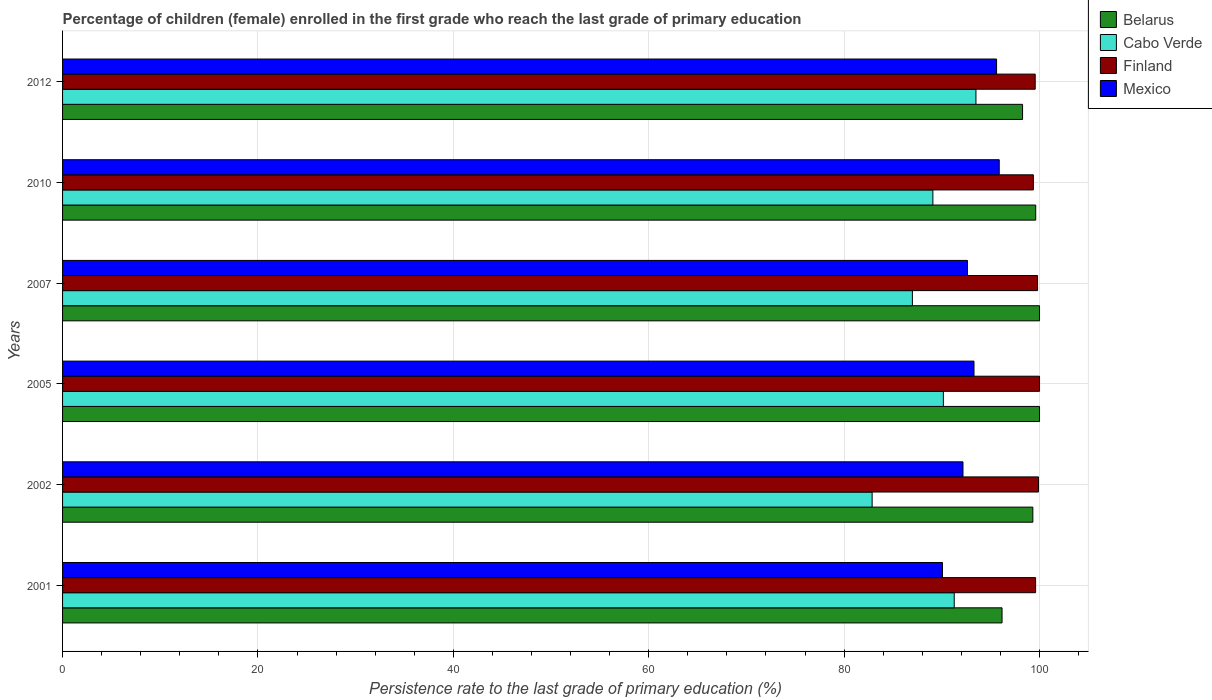How many bars are there on the 1st tick from the top?
Provide a short and direct response. 4. What is the label of the 4th group of bars from the top?
Your response must be concise. 2005. What is the persistence rate of children in Finland in 2001?
Offer a terse response. 99.6. Across all years, what is the maximum persistence rate of children in Cabo Verde?
Offer a terse response. 93.49. Across all years, what is the minimum persistence rate of children in Finland?
Offer a terse response. 99.37. In which year was the persistence rate of children in Cabo Verde maximum?
Your answer should be very brief. 2012. In which year was the persistence rate of children in Cabo Verde minimum?
Provide a succinct answer. 2002. What is the total persistence rate of children in Finland in the graph?
Provide a short and direct response. 598.21. What is the difference between the persistence rate of children in Finland in 2002 and that in 2012?
Offer a very short reply. 0.34. What is the difference between the persistence rate of children in Cabo Verde in 2005 and the persistence rate of children in Mexico in 2012?
Your answer should be very brief. -5.45. What is the average persistence rate of children in Cabo Verde per year?
Give a very brief answer. 88.98. In the year 2002, what is the difference between the persistence rate of children in Mexico and persistence rate of children in Cabo Verde?
Give a very brief answer. 9.3. In how many years, is the persistence rate of children in Mexico greater than 36 %?
Provide a succinct answer. 6. What is the ratio of the persistence rate of children in Finland in 2001 to that in 2007?
Keep it short and to the point. 1. Is the persistence rate of children in Cabo Verde in 2001 less than that in 2005?
Offer a terse response. No. Is the difference between the persistence rate of children in Mexico in 2005 and 2012 greater than the difference between the persistence rate of children in Cabo Verde in 2005 and 2012?
Your response must be concise. Yes. What is the difference between the highest and the second highest persistence rate of children in Mexico?
Offer a very short reply. 0.27. What is the difference between the highest and the lowest persistence rate of children in Mexico?
Provide a short and direct response. 5.81. Is the sum of the persistence rate of children in Belarus in 2001 and 2012 greater than the maximum persistence rate of children in Finland across all years?
Offer a very short reply. Yes. Is it the case that in every year, the sum of the persistence rate of children in Mexico and persistence rate of children in Finland is greater than the sum of persistence rate of children in Cabo Verde and persistence rate of children in Belarus?
Give a very brief answer. Yes. What does the 1st bar from the top in 2001 represents?
Keep it short and to the point. Mexico. Is it the case that in every year, the sum of the persistence rate of children in Finland and persistence rate of children in Belarus is greater than the persistence rate of children in Cabo Verde?
Keep it short and to the point. Yes. Are the values on the major ticks of X-axis written in scientific E-notation?
Give a very brief answer. No. Does the graph contain grids?
Provide a short and direct response. Yes. How many legend labels are there?
Offer a terse response. 4. What is the title of the graph?
Give a very brief answer. Percentage of children (female) enrolled in the first grade who reach the last grade of primary education. Does "Upper middle income" appear as one of the legend labels in the graph?
Offer a terse response. No. What is the label or title of the X-axis?
Keep it short and to the point. Persistence rate to the last grade of primary education (%). What is the Persistence rate to the last grade of primary education (%) of Belarus in 2001?
Give a very brief answer. 96.16. What is the Persistence rate to the last grade of primary education (%) of Cabo Verde in 2001?
Give a very brief answer. 91.27. What is the Persistence rate to the last grade of primary education (%) of Finland in 2001?
Provide a short and direct response. 99.6. What is the Persistence rate to the last grade of primary education (%) in Mexico in 2001?
Make the answer very short. 90.07. What is the Persistence rate to the last grade of primary education (%) of Belarus in 2002?
Make the answer very short. 99.32. What is the Persistence rate to the last grade of primary education (%) of Cabo Verde in 2002?
Provide a short and direct response. 82.87. What is the Persistence rate to the last grade of primary education (%) of Finland in 2002?
Offer a very short reply. 99.9. What is the Persistence rate to the last grade of primary education (%) in Mexico in 2002?
Ensure brevity in your answer.  92.17. What is the Persistence rate to the last grade of primary education (%) in Cabo Verde in 2005?
Provide a short and direct response. 90.16. What is the Persistence rate to the last grade of primary education (%) in Mexico in 2005?
Offer a terse response. 93.29. What is the Persistence rate to the last grade of primary education (%) in Cabo Verde in 2007?
Provide a short and direct response. 86.99. What is the Persistence rate to the last grade of primary education (%) of Finland in 2007?
Give a very brief answer. 99.8. What is the Persistence rate to the last grade of primary education (%) of Mexico in 2007?
Your answer should be compact. 92.62. What is the Persistence rate to the last grade of primary education (%) in Belarus in 2010?
Offer a terse response. 99.61. What is the Persistence rate to the last grade of primary education (%) of Cabo Verde in 2010?
Offer a very short reply. 89.08. What is the Persistence rate to the last grade of primary education (%) in Finland in 2010?
Your answer should be compact. 99.37. What is the Persistence rate to the last grade of primary education (%) in Mexico in 2010?
Give a very brief answer. 95.88. What is the Persistence rate to the last grade of primary education (%) in Belarus in 2012?
Your answer should be compact. 98.26. What is the Persistence rate to the last grade of primary education (%) in Cabo Verde in 2012?
Give a very brief answer. 93.49. What is the Persistence rate to the last grade of primary education (%) of Finland in 2012?
Your answer should be very brief. 99.56. What is the Persistence rate to the last grade of primary education (%) of Mexico in 2012?
Your answer should be compact. 95.6. Across all years, what is the maximum Persistence rate to the last grade of primary education (%) in Cabo Verde?
Your answer should be very brief. 93.49. Across all years, what is the maximum Persistence rate to the last grade of primary education (%) of Mexico?
Your response must be concise. 95.88. Across all years, what is the minimum Persistence rate to the last grade of primary education (%) of Belarus?
Provide a succinct answer. 96.16. Across all years, what is the minimum Persistence rate to the last grade of primary education (%) of Cabo Verde?
Offer a very short reply. 82.87. Across all years, what is the minimum Persistence rate to the last grade of primary education (%) of Finland?
Provide a short and direct response. 99.37. Across all years, what is the minimum Persistence rate to the last grade of primary education (%) in Mexico?
Ensure brevity in your answer.  90.07. What is the total Persistence rate to the last grade of primary education (%) of Belarus in the graph?
Provide a short and direct response. 593.35. What is the total Persistence rate to the last grade of primary education (%) in Cabo Verde in the graph?
Keep it short and to the point. 533.85. What is the total Persistence rate to the last grade of primary education (%) of Finland in the graph?
Offer a terse response. 598.21. What is the total Persistence rate to the last grade of primary education (%) in Mexico in the graph?
Provide a succinct answer. 559.63. What is the difference between the Persistence rate to the last grade of primary education (%) of Belarus in 2001 and that in 2002?
Offer a terse response. -3.15. What is the difference between the Persistence rate to the last grade of primary education (%) of Cabo Verde in 2001 and that in 2002?
Ensure brevity in your answer.  8.4. What is the difference between the Persistence rate to the last grade of primary education (%) in Finland in 2001 and that in 2002?
Your answer should be very brief. -0.3. What is the difference between the Persistence rate to the last grade of primary education (%) in Mexico in 2001 and that in 2002?
Offer a very short reply. -2.1. What is the difference between the Persistence rate to the last grade of primary education (%) of Belarus in 2001 and that in 2005?
Your answer should be compact. -3.84. What is the difference between the Persistence rate to the last grade of primary education (%) of Cabo Verde in 2001 and that in 2005?
Ensure brevity in your answer.  1.11. What is the difference between the Persistence rate to the last grade of primary education (%) of Finland in 2001 and that in 2005?
Offer a very short reply. -0.4. What is the difference between the Persistence rate to the last grade of primary education (%) in Mexico in 2001 and that in 2005?
Provide a succinct answer. -3.23. What is the difference between the Persistence rate to the last grade of primary education (%) in Belarus in 2001 and that in 2007?
Offer a terse response. -3.84. What is the difference between the Persistence rate to the last grade of primary education (%) in Cabo Verde in 2001 and that in 2007?
Ensure brevity in your answer.  4.28. What is the difference between the Persistence rate to the last grade of primary education (%) of Finland in 2001 and that in 2007?
Keep it short and to the point. -0.2. What is the difference between the Persistence rate to the last grade of primary education (%) of Mexico in 2001 and that in 2007?
Keep it short and to the point. -2.56. What is the difference between the Persistence rate to the last grade of primary education (%) in Belarus in 2001 and that in 2010?
Give a very brief answer. -3.45. What is the difference between the Persistence rate to the last grade of primary education (%) in Cabo Verde in 2001 and that in 2010?
Ensure brevity in your answer.  2.19. What is the difference between the Persistence rate to the last grade of primary education (%) in Finland in 2001 and that in 2010?
Give a very brief answer. 0.23. What is the difference between the Persistence rate to the last grade of primary education (%) of Mexico in 2001 and that in 2010?
Offer a terse response. -5.81. What is the difference between the Persistence rate to the last grade of primary education (%) in Belarus in 2001 and that in 2012?
Keep it short and to the point. -2.1. What is the difference between the Persistence rate to the last grade of primary education (%) in Cabo Verde in 2001 and that in 2012?
Your response must be concise. -2.22. What is the difference between the Persistence rate to the last grade of primary education (%) of Finland in 2001 and that in 2012?
Keep it short and to the point. 0.04. What is the difference between the Persistence rate to the last grade of primary education (%) of Mexico in 2001 and that in 2012?
Offer a very short reply. -5.54. What is the difference between the Persistence rate to the last grade of primary education (%) of Belarus in 2002 and that in 2005?
Offer a very short reply. -0.68. What is the difference between the Persistence rate to the last grade of primary education (%) of Cabo Verde in 2002 and that in 2005?
Offer a very short reply. -7.29. What is the difference between the Persistence rate to the last grade of primary education (%) of Finland in 2002 and that in 2005?
Offer a terse response. -0.1. What is the difference between the Persistence rate to the last grade of primary education (%) of Mexico in 2002 and that in 2005?
Give a very brief answer. -1.13. What is the difference between the Persistence rate to the last grade of primary education (%) of Belarus in 2002 and that in 2007?
Your answer should be compact. -0.68. What is the difference between the Persistence rate to the last grade of primary education (%) in Cabo Verde in 2002 and that in 2007?
Give a very brief answer. -4.12. What is the difference between the Persistence rate to the last grade of primary education (%) in Finland in 2002 and that in 2007?
Keep it short and to the point. 0.1. What is the difference between the Persistence rate to the last grade of primary education (%) of Mexico in 2002 and that in 2007?
Your answer should be compact. -0.46. What is the difference between the Persistence rate to the last grade of primary education (%) in Belarus in 2002 and that in 2010?
Ensure brevity in your answer.  -0.29. What is the difference between the Persistence rate to the last grade of primary education (%) of Cabo Verde in 2002 and that in 2010?
Provide a succinct answer. -6.22. What is the difference between the Persistence rate to the last grade of primary education (%) in Finland in 2002 and that in 2010?
Your answer should be very brief. 0.53. What is the difference between the Persistence rate to the last grade of primary education (%) of Mexico in 2002 and that in 2010?
Offer a terse response. -3.71. What is the difference between the Persistence rate to the last grade of primary education (%) in Belarus in 2002 and that in 2012?
Provide a short and direct response. 1.05. What is the difference between the Persistence rate to the last grade of primary education (%) of Cabo Verde in 2002 and that in 2012?
Your answer should be very brief. -10.63. What is the difference between the Persistence rate to the last grade of primary education (%) in Finland in 2002 and that in 2012?
Offer a very short reply. 0.34. What is the difference between the Persistence rate to the last grade of primary education (%) in Mexico in 2002 and that in 2012?
Make the answer very short. -3.44. What is the difference between the Persistence rate to the last grade of primary education (%) of Cabo Verde in 2005 and that in 2007?
Make the answer very short. 3.17. What is the difference between the Persistence rate to the last grade of primary education (%) of Finland in 2005 and that in 2007?
Ensure brevity in your answer.  0.2. What is the difference between the Persistence rate to the last grade of primary education (%) of Mexico in 2005 and that in 2007?
Keep it short and to the point. 0.67. What is the difference between the Persistence rate to the last grade of primary education (%) in Belarus in 2005 and that in 2010?
Offer a very short reply. 0.39. What is the difference between the Persistence rate to the last grade of primary education (%) in Cabo Verde in 2005 and that in 2010?
Provide a succinct answer. 1.07. What is the difference between the Persistence rate to the last grade of primary education (%) in Finland in 2005 and that in 2010?
Provide a short and direct response. 0.63. What is the difference between the Persistence rate to the last grade of primary education (%) in Mexico in 2005 and that in 2010?
Ensure brevity in your answer.  -2.58. What is the difference between the Persistence rate to the last grade of primary education (%) in Belarus in 2005 and that in 2012?
Provide a short and direct response. 1.74. What is the difference between the Persistence rate to the last grade of primary education (%) of Cabo Verde in 2005 and that in 2012?
Offer a very short reply. -3.34. What is the difference between the Persistence rate to the last grade of primary education (%) of Finland in 2005 and that in 2012?
Give a very brief answer. 0.44. What is the difference between the Persistence rate to the last grade of primary education (%) of Mexico in 2005 and that in 2012?
Provide a succinct answer. -2.31. What is the difference between the Persistence rate to the last grade of primary education (%) of Belarus in 2007 and that in 2010?
Your answer should be compact. 0.39. What is the difference between the Persistence rate to the last grade of primary education (%) of Cabo Verde in 2007 and that in 2010?
Give a very brief answer. -2.1. What is the difference between the Persistence rate to the last grade of primary education (%) in Finland in 2007 and that in 2010?
Your answer should be compact. 0.43. What is the difference between the Persistence rate to the last grade of primary education (%) of Mexico in 2007 and that in 2010?
Give a very brief answer. -3.25. What is the difference between the Persistence rate to the last grade of primary education (%) in Belarus in 2007 and that in 2012?
Offer a terse response. 1.74. What is the difference between the Persistence rate to the last grade of primary education (%) of Cabo Verde in 2007 and that in 2012?
Provide a short and direct response. -6.51. What is the difference between the Persistence rate to the last grade of primary education (%) of Finland in 2007 and that in 2012?
Give a very brief answer. 0.24. What is the difference between the Persistence rate to the last grade of primary education (%) of Mexico in 2007 and that in 2012?
Give a very brief answer. -2.98. What is the difference between the Persistence rate to the last grade of primary education (%) in Belarus in 2010 and that in 2012?
Your answer should be compact. 1.34. What is the difference between the Persistence rate to the last grade of primary education (%) of Cabo Verde in 2010 and that in 2012?
Your response must be concise. -4.41. What is the difference between the Persistence rate to the last grade of primary education (%) of Finland in 2010 and that in 2012?
Your response must be concise. -0.19. What is the difference between the Persistence rate to the last grade of primary education (%) of Mexico in 2010 and that in 2012?
Your response must be concise. 0.27. What is the difference between the Persistence rate to the last grade of primary education (%) in Belarus in 2001 and the Persistence rate to the last grade of primary education (%) in Cabo Verde in 2002?
Your answer should be compact. 13.3. What is the difference between the Persistence rate to the last grade of primary education (%) of Belarus in 2001 and the Persistence rate to the last grade of primary education (%) of Finland in 2002?
Your response must be concise. -3.73. What is the difference between the Persistence rate to the last grade of primary education (%) in Belarus in 2001 and the Persistence rate to the last grade of primary education (%) in Mexico in 2002?
Provide a succinct answer. 4. What is the difference between the Persistence rate to the last grade of primary education (%) of Cabo Verde in 2001 and the Persistence rate to the last grade of primary education (%) of Finland in 2002?
Make the answer very short. -8.63. What is the difference between the Persistence rate to the last grade of primary education (%) of Cabo Verde in 2001 and the Persistence rate to the last grade of primary education (%) of Mexico in 2002?
Ensure brevity in your answer.  -0.9. What is the difference between the Persistence rate to the last grade of primary education (%) in Finland in 2001 and the Persistence rate to the last grade of primary education (%) in Mexico in 2002?
Your answer should be compact. 7.43. What is the difference between the Persistence rate to the last grade of primary education (%) of Belarus in 2001 and the Persistence rate to the last grade of primary education (%) of Cabo Verde in 2005?
Your answer should be compact. 6.01. What is the difference between the Persistence rate to the last grade of primary education (%) in Belarus in 2001 and the Persistence rate to the last grade of primary education (%) in Finland in 2005?
Ensure brevity in your answer.  -3.84. What is the difference between the Persistence rate to the last grade of primary education (%) in Belarus in 2001 and the Persistence rate to the last grade of primary education (%) in Mexico in 2005?
Give a very brief answer. 2.87. What is the difference between the Persistence rate to the last grade of primary education (%) in Cabo Verde in 2001 and the Persistence rate to the last grade of primary education (%) in Finland in 2005?
Your answer should be very brief. -8.73. What is the difference between the Persistence rate to the last grade of primary education (%) of Cabo Verde in 2001 and the Persistence rate to the last grade of primary education (%) of Mexico in 2005?
Make the answer very short. -2.02. What is the difference between the Persistence rate to the last grade of primary education (%) in Finland in 2001 and the Persistence rate to the last grade of primary education (%) in Mexico in 2005?
Offer a very short reply. 6.31. What is the difference between the Persistence rate to the last grade of primary education (%) in Belarus in 2001 and the Persistence rate to the last grade of primary education (%) in Cabo Verde in 2007?
Your answer should be compact. 9.18. What is the difference between the Persistence rate to the last grade of primary education (%) in Belarus in 2001 and the Persistence rate to the last grade of primary education (%) in Finland in 2007?
Provide a short and direct response. -3.63. What is the difference between the Persistence rate to the last grade of primary education (%) of Belarus in 2001 and the Persistence rate to the last grade of primary education (%) of Mexico in 2007?
Give a very brief answer. 3.54. What is the difference between the Persistence rate to the last grade of primary education (%) in Cabo Verde in 2001 and the Persistence rate to the last grade of primary education (%) in Finland in 2007?
Your answer should be very brief. -8.53. What is the difference between the Persistence rate to the last grade of primary education (%) in Cabo Verde in 2001 and the Persistence rate to the last grade of primary education (%) in Mexico in 2007?
Your answer should be compact. -1.35. What is the difference between the Persistence rate to the last grade of primary education (%) in Finland in 2001 and the Persistence rate to the last grade of primary education (%) in Mexico in 2007?
Provide a short and direct response. 6.97. What is the difference between the Persistence rate to the last grade of primary education (%) in Belarus in 2001 and the Persistence rate to the last grade of primary education (%) in Cabo Verde in 2010?
Provide a short and direct response. 7.08. What is the difference between the Persistence rate to the last grade of primary education (%) of Belarus in 2001 and the Persistence rate to the last grade of primary education (%) of Finland in 2010?
Give a very brief answer. -3.21. What is the difference between the Persistence rate to the last grade of primary education (%) of Belarus in 2001 and the Persistence rate to the last grade of primary education (%) of Mexico in 2010?
Ensure brevity in your answer.  0.29. What is the difference between the Persistence rate to the last grade of primary education (%) of Cabo Verde in 2001 and the Persistence rate to the last grade of primary education (%) of Finland in 2010?
Provide a succinct answer. -8.1. What is the difference between the Persistence rate to the last grade of primary education (%) in Cabo Verde in 2001 and the Persistence rate to the last grade of primary education (%) in Mexico in 2010?
Your response must be concise. -4.61. What is the difference between the Persistence rate to the last grade of primary education (%) in Finland in 2001 and the Persistence rate to the last grade of primary education (%) in Mexico in 2010?
Ensure brevity in your answer.  3.72. What is the difference between the Persistence rate to the last grade of primary education (%) in Belarus in 2001 and the Persistence rate to the last grade of primary education (%) in Cabo Verde in 2012?
Offer a very short reply. 2.67. What is the difference between the Persistence rate to the last grade of primary education (%) of Belarus in 2001 and the Persistence rate to the last grade of primary education (%) of Finland in 2012?
Offer a very short reply. -3.4. What is the difference between the Persistence rate to the last grade of primary education (%) of Belarus in 2001 and the Persistence rate to the last grade of primary education (%) of Mexico in 2012?
Give a very brief answer. 0.56. What is the difference between the Persistence rate to the last grade of primary education (%) of Cabo Verde in 2001 and the Persistence rate to the last grade of primary education (%) of Finland in 2012?
Provide a succinct answer. -8.29. What is the difference between the Persistence rate to the last grade of primary education (%) of Cabo Verde in 2001 and the Persistence rate to the last grade of primary education (%) of Mexico in 2012?
Your response must be concise. -4.33. What is the difference between the Persistence rate to the last grade of primary education (%) in Finland in 2001 and the Persistence rate to the last grade of primary education (%) in Mexico in 2012?
Offer a terse response. 3.99. What is the difference between the Persistence rate to the last grade of primary education (%) in Belarus in 2002 and the Persistence rate to the last grade of primary education (%) in Cabo Verde in 2005?
Provide a succinct answer. 9.16. What is the difference between the Persistence rate to the last grade of primary education (%) of Belarus in 2002 and the Persistence rate to the last grade of primary education (%) of Finland in 2005?
Keep it short and to the point. -0.68. What is the difference between the Persistence rate to the last grade of primary education (%) in Belarus in 2002 and the Persistence rate to the last grade of primary education (%) in Mexico in 2005?
Give a very brief answer. 6.02. What is the difference between the Persistence rate to the last grade of primary education (%) in Cabo Verde in 2002 and the Persistence rate to the last grade of primary education (%) in Finland in 2005?
Give a very brief answer. -17.13. What is the difference between the Persistence rate to the last grade of primary education (%) in Cabo Verde in 2002 and the Persistence rate to the last grade of primary education (%) in Mexico in 2005?
Make the answer very short. -10.43. What is the difference between the Persistence rate to the last grade of primary education (%) of Finland in 2002 and the Persistence rate to the last grade of primary education (%) of Mexico in 2005?
Offer a terse response. 6.6. What is the difference between the Persistence rate to the last grade of primary education (%) of Belarus in 2002 and the Persistence rate to the last grade of primary education (%) of Cabo Verde in 2007?
Keep it short and to the point. 12.33. What is the difference between the Persistence rate to the last grade of primary education (%) of Belarus in 2002 and the Persistence rate to the last grade of primary education (%) of Finland in 2007?
Your response must be concise. -0.48. What is the difference between the Persistence rate to the last grade of primary education (%) of Belarus in 2002 and the Persistence rate to the last grade of primary education (%) of Mexico in 2007?
Make the answer very short. 6.69. What is the difference between the Persistence rate to the last grade of primary education (%) of Cabo Verde in 2002 and the Persistence rate to the last grade of primary education (%) of Finland in 2007?
Keep it short and to the point. -16.93. What is the difference between the Persistence rate to the last grade of primary education (%) of Cabo Verde in 2002 and the Persistence rate to the last grade of primary education (%) of Mexico in 2007?
Your answer should be compact. -9.76. What is the difference between the Persistence rate to the last grade of primary education (%) of Finland in 2002 and the Persistence rate to the last grade of primary education (%) of Mexico in 2007?
Your answer should be very brief. 7.27. What is the difference between the Persistence rate to the last grade of primary education (%) of Belarus in 2002 and the Persistence rate to the last grade of primary education (%) of Cabo Verde in 2010?
Provide a succinct answer. 10.23. What is the difference between the Persistence rate to the last grade of primary education (%) in Belarus in 2002 and the Persistence rate to the last grade of primary education (%) in Finland in 2010?
Your response must be concise. -0.05. What is the difference between the Persistence rate to the last grade of primary education (%) of Belarus in 2002 and the Persistence rate to the last grade of primary education (%) of Mexico in 2010?
Keep it short and to the point. 3.44. What is the difference between the Persistence rate to the last grade of primary education (%) of Cabo Verde in 2002 and the Persistence rate to the last grade of primary education (%) of Finland in 2010?
Your response must be concise. -16.5. What is the difference between the Persistence rate to the last grade of primary education (%) in Cabo Verde in 2002 and the Persistence rate to the last grade of primary education (%) in Mexico in 2010?
Your answer should be compact. -13.01. What is the difference between the Persistence rate to the last grade of primary education (%) of Finland in 2002 and the Persistence rate to the last grade of primary education (%) of Mexico in 2010?
Your answer should be very brief. 4.02. What is the difference between the Persistence rate to the last grade of primary education (%) of Belarus in 2002 and the Persistence rate to the last grade of primary education (%) of Cabo Verde in 2012?
Your response must be concise. 5.82. What is the difference between the Persistence rate to the last grade of primary education (%) in Belarus in 2002 and the Persistence rate to the last grade of primary education (%) in Finland in 2012?
Offer a very short reply. -0.24. What is the difference between the Persistence rate to the last grade of primary education (%) of Belarus in 2002 and the Persistence rate to the last grade of primary education (%) of Mexico in 2012?
Offer a very short reply. 3.71. What is the difference between the Persistence rate to the last grade of primary education (%) in Cabo Verde in 2002 and the Persistence rate to the last grade of primary education (%) in Finland in 2012?
Offer a very short reply. -16.69. What is the difference between the Persistence rate to the last grade of primary education (%) in Cabo Verde in 2002 and the Persistence rate to the last grade of primary education (%) in Mexico in 2012?
Offer a terse response. -12.74. What is the difference between the Persistence rate to the last grade of primary education (%) of Finland in 2002 and the Persistence rate to the last grade of primary education (%) of Mexico in 2012?
Provide a succinct answer. 4.29. What is the difference between the Persistence rate to the last grade of primary education (%) of Belarus in 2005 and the Persistence rate to the last grade of primary education (%) of Cabo Verde in 2007?
Your answer should be compact. 13.01. What is the difference between the Persistence rate to the last grade of primary education (%) of Belarus in 2005 and the Persistence rate to the last grade of primary education (%) of Finland in 2007?
Give a very brief answer. 0.2. What is the difference between the Persistence rate to the last grade of primary education (%) of Belarus in 2005 and the Persistence rate to the last grade of primary education (%) of Mexico in 2007?
Provide a succinct answer. 7.38. What is the difference between the Persistence rate to the last grade of primary education (%) of Cabo Verde in 2005 and the Persistence rate to the last grade of primary education (%) of Finland in 2007?
Offer a terse response. -9.64. What is the difference between the Persistence rate to the last grade of primary education (%) in Cabo Verde in 2005 and the Persistence rate to the last grade of primary education (%) in Mexico in 2007?
Your answer should be compact. -2.47. What is the difference between the Persistence rate to the last grade of primary education (%) of Finland in 2005 and the Persistence rate to the last grade of primary education (%) of Mexico in 2007?
Your answer should be very brief. 7.38. What is the difference between the Persistence rate to the last grade of primary education (%) of Belarus in 2005 and the Persistence rate to the last grade of primary education (%) of Cabo Verde in 2010?
Provide a succinct answer. 10.92. What is the difference between the Persistence rate to the last grade of primary education (%) of Belarus in 2005 and the Persistence rate to the last grade of primary education (%) of Finland in 2010?
Provide a short and direct response. 0.63. What is the difference between the Persistence rate to the last grade of primary education (%) of Belarus in 2005 and the Persistence rate to the last grade of primary education (%) of Mexico in 2010?
Provide a succinct answer. 4.12. What is the difference between the Persistence rate to the last grade of primary education (%) in Cabo Verde in 2005 and the Persistence rate to the last grade of primary education (%) in Finland in 2010?
Give a very brief answer. -9.21. What is the difference between the Persistence rate to the last grade of primary education (%) in Cabo Verde in 2005 and the Persistence rate to the last grade of primary education (%) in Mexico in 2010?
Your answer should be compact. -5.72. What is the difference between the Persistence rate to the last grade of primary education (%) of Finland in 2005 and the Persistence rate to the last grade of primary education (%) of Mexico in 2010?
Provide a succinct answer. 4.12. What is the difference between the Persistence rate to the last grade of primary education (%) of Belarus in 2005 and the Persistence rate to the last grade of primary education (%) of Cabo Verde in 2012?
Keep it short and to the point. 6.51. What is the difference between the Persistence rate to the last grade of primary education (%) of Belarus in 2005 and the Persistence rate to the last grade of primary education (%) of Finland in 2012?
Your response must be concise. 0.44. What is the difference between the Persistence rate to the last grade of primary education (%) of Belarus in 2005 and the Persistence rate to the last grade of primary education (%) of Mexico in 2012?
Your answer should be compact. 4.4. What is the difference between the Persistence rate to the last grade of primary education (%) of Cabo Verde in 2005 and the Persistence rate to the last grade of primary education (%) of Finland in 2012?
Your answer should be very brief. -9.4. What is the difference between the Persistence rate to the last grade of primary education (%) of Cabo Verde in 2005 and the Persistence rate to the last grade of primary education (%) of Mexico in 2012?
Keep it short and to the point. -5.45. What is the difference between the Persistence rate to the last grade of primary education (%) of Finland in 2005 and the Persistence rate to the last grade of primary education (%) of Mexico in 2012?
Make the answer very short. 4.4. What is the difference between the Persistence rate to the last grade of primary education (%) of Belarus in 2007 and the Persistence rate to the last grade of primary education (%) of Cabo Verde in 2010?
Keep it short and to the point. 10.92. What is the difference between the Persistence rate to the last grade of primary education (%) in Belarus in 2007 and the Persistence rate to the last grade of primary education (%) in Finland in 2010?
Provide a succinct answer. 0.63. What is the difference between the Persistence rate to the last grade of primary education (%) in Belarus in 2007 and the Persistence rate to the last grade of primary education (%) in Mexico in 2010?
Give a very brief answer. 4.12. What is the difference between the Persistence rate to the last grade of primary education (%) of Cabo Verde in 2007 and the Persistence rate to the last grade of primary education (%) of Finland in 2010?
Offer a terse response. -12.38. What is the difference between the Persistence rate to the last grade of primary education (%) of Cabo Verde in 2007 and the Persistence rate to the last grade of primary education (%) of Mexico in 2010?
Your answer should be very brief. -8.89. What is the difference between the Persistence rate to the last grade of primary education (%) in Finland in 2007 and the Persistence rate to the last grade of primary education (%) in Mexico in 2010?
Offer a very short reply. 3.92. What is the difference between the Persistence rate to the last grade of primary education (%) in Belarus in 2007 and the Persistence rate to the last grade of primary education (%) in Cabo Verde in 2012?
Offer a terse response. 6.51. What is the difference between the Persistence rate to the last grade of primary education (%) of Belarus in 2007 and the Persistence rate to the last grade of primary education (%) of Finland in 2012?
Offer a terse response. 0.44. What is the difference between the Persistence rate to the last grade of primary education (%) of Belarus in 2007 and the Persistence rate to the last grade of primary education (%) of Mexico in 2012?
Offer a very short reply. 4.4. What is the difference between the Persistence rate to the last grade of primary education (%) of Cabo Verde in 2007 and the Persistence rate to the last grade of primary education (%) of Finland in 2012?
Offer a terse response. -12.57. What is the difference between the Persistence rate to the last grade of primary education (%) of Cabo Verde in 2007 and the Persistence rate to the last grade of primary education (%) of Mexico in 2012?
Your response must be concise. -8.62. What is the difference between the Persistence rate to the last grade of primary education (%) of Finland in 2007 and the Persistence rate to the last grade of primary education (%) of Mexico in 2012?
Offer a very short reply. 4.19. What is the difference between the Persistence rate to the last grade of primary education (%) in Belarus in 2010 and the Persistence rate to the last grade of primary education (%) in Cabo Verde in 2012?
Offer a very short reply. 6.11. What is the difference between the Persistence rate to the last grade of primary education (%) in Belarus in 2010 and the Persistence rate to the last grade of primary education (%) in Mexico in 2012?
Keep it short and to the point. 4. What is the difference between the Persistence rate to the last grade of primary education (%) of Cabo Verde in 2010 and the Persistence rate to the last grade of primary education (%) of Finland in 2012?
Provide a succinct answer. -10.47. What is the difference between the Persistence rate to the last grade of primary education (%) in Cabo Verde in 2010 and the Persistence rate to the last grade of primary education (%) in Mexico in 2012?
Offer a very short reply. -6.52. What is the difference between the Persistence rate to the last grade of primary education (%) of Finland in 2010 and the Persistence rate to the last grade of primary education (%) of Mexico in 2012?
Your answer should be very brief. 3.76. What is the average Persistence rate to the last grade of primary education (%) in Belarus per year?
Keep it short and to the point. 98.89. What is the average Persistence rate to the last grade of primary education (%) of Cabo Verde per year?
Offer a terse response. 88.98. What is the average Persistence rate to the last grade of primary education (%) of Finland per year?
Provide a succinct answer. 99.7. What is the average Persistence rate to the last grade of primary education (%) of Mexico per year?
Offer a very short reply. 93.27. In the year 2001, what is the difference between the Persistence rate to the last grade of primary education (%) in Belarus and Persistence rate to the last grade of primary education (%) in Cabo Verde?
Offer a very short reply. 4.89. In the year 2001, what is the difference between the Persistence rate to the last grade of primary education (%) of Belarus and Persistence rate to the last grade of primary education (%) of Finland?
Keep it short and to the point. -3.44. In the year 2001, what is the difference between the Persistence rate to the last grade of primary education (%) in Belarus and Persistence rate to the last grade of primary education (%) in Mexico?
Offer a very short reply. 6.1. In the year 2001, what is the difference between the Persistence rate to the last grade of primary education (%) of Cabo Verde and Persistence rate to the last grade of primary education (%) of Finland?
Your answer should be very brief. -8.33. In the year 2001, what is the difference between the Persistence rate to the last grade of primary education (%) in Cabo Verde and Persistence rate to the last grade of primary education (%) in Mexico?
Your response must be concise. 1.2. In the year 2001, what is the difference between the Persistence rate to the last grade of primary education (%) in Finland and Persistence rate to the last grade of primary education (%) in Mexico?
Ensure brevity in your answer.  9.53. In the year 2002, what is the difference between the Persistence rate to the last grade of primary education (%) in Belarus and Persistence rate to the last grade of primary education (%) in Cabo Verde?
Keep it short and to the point. 16.45. In the year 2002, what is the difference between the Persistence rate to the last grade of primary education (%) of Belarus and Persistence rate to the last grade of primary education (%) of Finland?
Offer a terse response. -0.58. In the year 2002, what is the difference between the Persistence rate to the last grade of primary education (%) in Belarus and Persistence rate to the last grade of primary education (%) in Mexico?
Give a very brief answer. 7.15. In the year 2002, what is the difference between the Persistence rate to the last grade of primary education (%) in Cabo Verde and Persistence rate to the last grade of primary education (%) in Finland?
Your answer should be very brief. -17.03. In the year 2002, what is the difference between the Persistence rate to the last grade of primary education (%) of Cabo Verde and Persistence rate to the last grade of primary education (%) of Mexico?
Give a very brief answer. -9.3. In the year 2002, what is the difference between the Persistence rate to the last grade of primary education (%) in Finland and Persistence rate to the last grade of primary education (%) in Mexico?
Give a very brief answer. 7.73. In the year 2005, what is the difference between the Persistence rate to the last grade of primary education (%) of Belarus and Persistence rate to the last grade of primary education (%) of Cabo Verde?
Ensure brevity in your answer.  9.84. In the year 2005, what is the difference between the Persistence rate to the last grade of primary education (%) in Belarus and Persistence rate to the last grade of primary education (%) in Mexico?
Your response must be concise. 6.71. In the year 2005, what is the difference between the Persistence rate to the last grade of primary education (%) of Cabo Verde and Persistence rate to the last grade of primary education (%) of Finland?
Your answer should be very brief. -9.84. In the year 2005, what is the difference between the Persistence rate to the last grade of primary education (%) in Cabo Verde and Persistence rate to the last grade of primary education (%) in Mexico?
Your answer should be compact. -3.14. In the year 2005, what is the difference between the Persistence rate to the last grade of primary education (%) in Finland and Persistence rate to the last grade of primary education (%) in Mexico?
Give a very brief answer. 6.71. In the year 2007, what is the difference between the Persistence rate to the last grade of primary education (%) of Belarus and Persistence rate to the last grade of primary education (%) of Cabo Verde?
Your answer should be very brief. 13.01. In the year 2007, what is the difference between the Persistence rate to the last grade of primary education (%) in Belarus and Persistence rate to the last grade of primary education (%) in Finland?
Your response must be concise. 0.2. In the year 2007, what is the difference between the Persistence rate to the last grade of primary education (%) of Belarus and Persistence rate to the last grade of primary education (%) of Mexico?
Offer a terse response. 7.38. In the year 2007, what is the difference between the Persistence rate to the last grade of primary education (%) of Cabo Verde and Persistence rate to the last grade of primary education (%) of Finland?
Offer a very short reply. -12.81. In the year 2007, what is the difference between the Persistence rate to the last grade of primary education (%) of Cabo Verde and Persistence rate to the last grade of primary education (%) of Mexico?
Make the answer very short. -5.64. In the year 2007, what is the difference between the Persistence rate to the last grade of primary education (%) of Finland and Persistence rate to the last grade of primary education (%) of Mexico?
Keep it short and to the point. 7.17. In the year 2010, what is the difference between the Persistence rate to the last grade of primary education (%) in Belarus and Persistence rate to the last grade of primary education (%) in Cabo Verde?
Keep it short and to the point. 10.53. In the year 2010, what is the difference between the Persistence rate to the last grade of primary education (%) in Belarus and Persistence rate to the last grade of primary education (%) in Finland?
Offer a very short reply. 0.24. In the year 2010, what is the difference between the Persistence rate to the last grade of primary education (%) of Belarus and Persistence rate to the last grade of primary education (%) of Mexico?
Ensure brevity in your answer.  3.73. In the year 2010, what is the difference between the Persistence rate to the last grade of primary education (%) of Cabo Verde and Persistence rate to the last grade of primary education (%) of Finland?
Your answer should be very brief. -10.28. In the year 2010, what is the difference between the Persistence rate to the last grade of primary education (%) of Cabo Verde and Persistence rate to the last grade of primary education (%) of Mexico?
Provide a short and direct response. -6.79. In the year 2010, what is the difference between the Persistence rate to the last grade of primary education (%) of Finland and Persistence rate to the last grade of primary education (%) of Mexico?
Provide a short and direct response. 3.49. In the year 2012, what is the difference between the Persistence rate to the last grade of primary education (%) of Belarus and Persistence rate to the last grade of primary education (%) of Cabo Verde?
Your answer should be compact. 4.77. In the year 2012, what is the difference between the Persistence rate to the last grade of primary education (%) in Belarus and Persistence rate to the last grade of primary education (%) in Finland?
Your answer should be very brief. -1.29. In the year 2012, what is the difference between the Persistence rate to the last grade of primary education (%) of Belarus and Persistence rate to the last grade of primary education (%) of Mexico?
Make the answer very short. 2.66. In the year 2012, what is the difference between the Persistence rate to the last grade of primary education (%) in Cabo Verde and Persistence rate to the last grade of primary education (%) in Finland?
Keep it short and to the point. -6.06. In the year 2012, what is the difference between the Persistence rate to the last grade of primary education (%) of Cabo Verde and Persistence rate to the last grade of primary education (%) of Mexico?
Offer a terse response. -2.11. In the year 2012, what is the difference between the Persistence rate to the last grade of primary education (%) in Finland and Persistence rate to the last grade of primary education (%) in Mexico?
Provide a short and direct response. 3.95. What is the ratio of the Persistence rate to the last grade of primary education (%) of Belarus in 2001 to that in 2002?
Provide a succinct answer. 0.97. What is the ratio of the Persistence rate to the last grade of primary education (%) in Cabo Verde in 2001 to that in 2002?
Make the answer very short. 1.1. What is the ratio of the Persistence rate to the last grade of primary education (%) of Mexico in 2001 to that in 2002?
Make the answer very short. 0.98. What is the ratio of the Persistence rate to the last grade of primary education (%) of Belarus in 2001 to that in 2005?
Your answer should be compact. 0.96. What is the ratio of the Persistence rate to the last grade of primary education (%) in Cabo Verde in 2001 to that in 2005?
Keep it short and to the point. 1.01. What is the ratio of the Persistence rate to the last grade of primary education (%) in Mexico in 2001 to that in 2005?
Offer a very short reply. 0.97. What is the ratio of the Persistence rate to the last grade of primary education (%) in Belarus in 2001 to that in 2007?
Your answer should be compact. 0.96. What is the ratio of the Persistence rate to the last grade of primary education (%) in Cabo Verde in 2001 to that in 2007?
Your answer should be compact. 1.05. What is the ratio of the Persistence rate to the last grade of primary education (%) of Mexico in 2001 to that in 2007?
Your answer should be very brief. 0.97. What is the ratio of the Persistence rate to the last grade of primary education (%) in Belarus in 2001 to that in 2010?
Ensure brevity in your answer.  0.97. What is the ratio of the Persistence rate to the last grade of primary education (%) of Cabo Verde in 2001 to that in 2010?
Offer a very short reply. 1.02. What is the ratio of the Persistence rate to the last grade of primary education (%) in Mexico in 2001 to that in 2010?
Your answer should be very brief. 0.94. What is the ratio of the Persistence rate to the last grade of primary education (%) in Belarus in 2001 to that in 2012?
Offer a very short reply. 0.98. What is the ratio of the Persistence rate to the last grade of primary education (%) of Cabo Verde in 2001 to that in 2012?
Make the answer very short. 0.98. What is the ratio of the Persistence rate to the last grade of primary education (%) in Mexico in 2001 to that in 2012?
Make the answer very short. 0.94. What is the ratio of the Persistence rate to the last grade of primary education (%) of Belarus in 2002 to that in 2005?
Your answer should be very brief. 0.99. What is the ratio of the Persistence rate to the last grade of primary education (%) in Cabo Verde in 2002 to that in 2005?
Your response must be concise. 0.92. What is the ratio of the Persistence rate to the last grade of primary education (%) in Mexico in 2002 to that in 2005?
Your answer should be very brief. 0.99. What is the ratio of the Persistence rate to the last grade of primary education (%) of Cabo Verde in 2002 to that in 2007?
Give a very brief answer. 0.95. What is the ratio of the Persistence rate to the last grade of primary education (%) in Belarus in 2002 to that in 2010?
Provide a succinct answer. 1. What is the ratio of the Persistence rate to the last grade of primary education (%) in Cabo Verde in 2002 to that in 2010?
Make the answer very short. 0.93. What is the ratio of the Persistence rate to the last grade of primary education (%) of Mexico in 2002 to that in 2010?
Provide a short and direct response. 0.96. What is the ratio of the Persistence rate to the last grade of primary education (%) in Belarus in 2002 to that in 2012?
Your answer should be very brief. 1.01. What is the ratio of the Persistence rate to the last grade of primary education (%) in Cabo Verde in 2002 to that in 2012?
Your response must be concise. 0.89. What is the ratio of the Persistence rate to the last grade of primary education (%) in Cabo Verde in 2005 to that in 2007?
Your answer should be compact. 1.04. What is the ratio of the Persistence rate to the last grade of primary education (%) of Finland in 2005 to that in 2007?
Make the answer very short. 1. What is the ratio of the Persistence rate to the last grade of primary education (%) of Cabo Verde in 2005 to that in 2010?
Your response must be concise. 1.01. What is the ratio of the Persistence rate to the last grade of primary education (%) of Finland in 2005 to that in 2010?
Provide a short and direct response. 1.01. What is the ratio of the Persistence rate to the last grade of primary education (%) in Mexico in 2005 to that in 2010?
Your response must be concise. 0.97. What is the ratio of the Persistence rate to the last grade of primary education (%) in Belarus in 2005 to that in 2012?
Offer a very short reply. 1.02. What is the ratio of the Persistence rate to the last grade of primary education (%) of Cabo Verde in 2005 to that in 2012?
Give a very brief answer. 0.96. What is the ratio of the Persistence rate to the last grade of primary education (%) in Finland in 2005 to that in 2012?
Offer a very short reply. 1. What is the ratio of the Persistence rate to the last grade of primary education (%) in Mexico in 2005 to that in 2012?
Your response must be concise. 0.98. What is the ratio of the Persistence rate to the last grade of primary education (%) of Cabo Verde in 2007 to that in 2010?
Provide a short and direct response. 0.98. What is the ratio of the Persistence rate to the last grade of primary education (%) in Finland in 2007 to that in 2010?
Offer a very short reply. 1. What is the ratio of the Persistence rate to the last grade of primary education (%) in Mexico in 2007 to that in 2010?
Keep it short and to the point. 0.97. What is the ratio of the Persistence rate to the last grade of primary education (%) of Belarus in 2007 to that in 2012?
Ensure brevity in your answer.  1.02. What is the ratio of the Persistence rate to the last grade of primary education (%) of Cabo Verde in 2007 to that in 2012?
Keep it short and to the point. 0.93. What is the ratio of the Persistence rate to the last grade of primary education (%) in Mexico in 2007 to that in 2012?
Provide a succinct answer. 0.97. What is the ratio of the Persistence rate to the last grade of primary education (%) in Belarus in 2010 to that in 2012?
Your answer should be compact. 1.01. What is the ratio of the Persistence rate to the last grade of primary education (%) of Cabo Verde in 2010 to that in 2012?
Ensure brevity in your answer.  0.95. What is the ratio of the Persistence rate to the last grade of primary education (%) of Mexico in 2010 to that in 2012?
Offer a terse response. 1. What is the difference between the highest and the second highest Persistence rate to the last grade of primary education (%) of Belarus?
Offer a very short reply. 0. What is the difference between the highest and the second highest Persistence rate to the last grade of primary education (%) in Cabo Verde?
Ensure brevity in your answer.  2.22. What is the difference between the highest and the second highest Persistence rate to the last grade of primary education (%) in Finland?
Provide a short and direct response. 0.1. What is the difference between the highest and the second highest Persistence rate to the last grade of primary education (%) of Mexico?
Provide a short and direct response. 0.27. What is the difference between the highest and the lowest Persistence rate to the last grade of primary education (%) of Belarus?
Keep it short and to the point. 3.84. What is the difference between the highest and the lowest Persistence rate to the last grade of primary education (%) in Cabo Verde?
Your response must be concise. 10.63. What is the difference between the highest and the lowest Persistence rate to the last grade of primary education (%) of Finland?
Provide a succinct answer. 0.63. What is the difference between the highest and the lowest Persistence rate to the last grade of primary education (%) of Mexico?
Offer a very short reply. 5.81. 